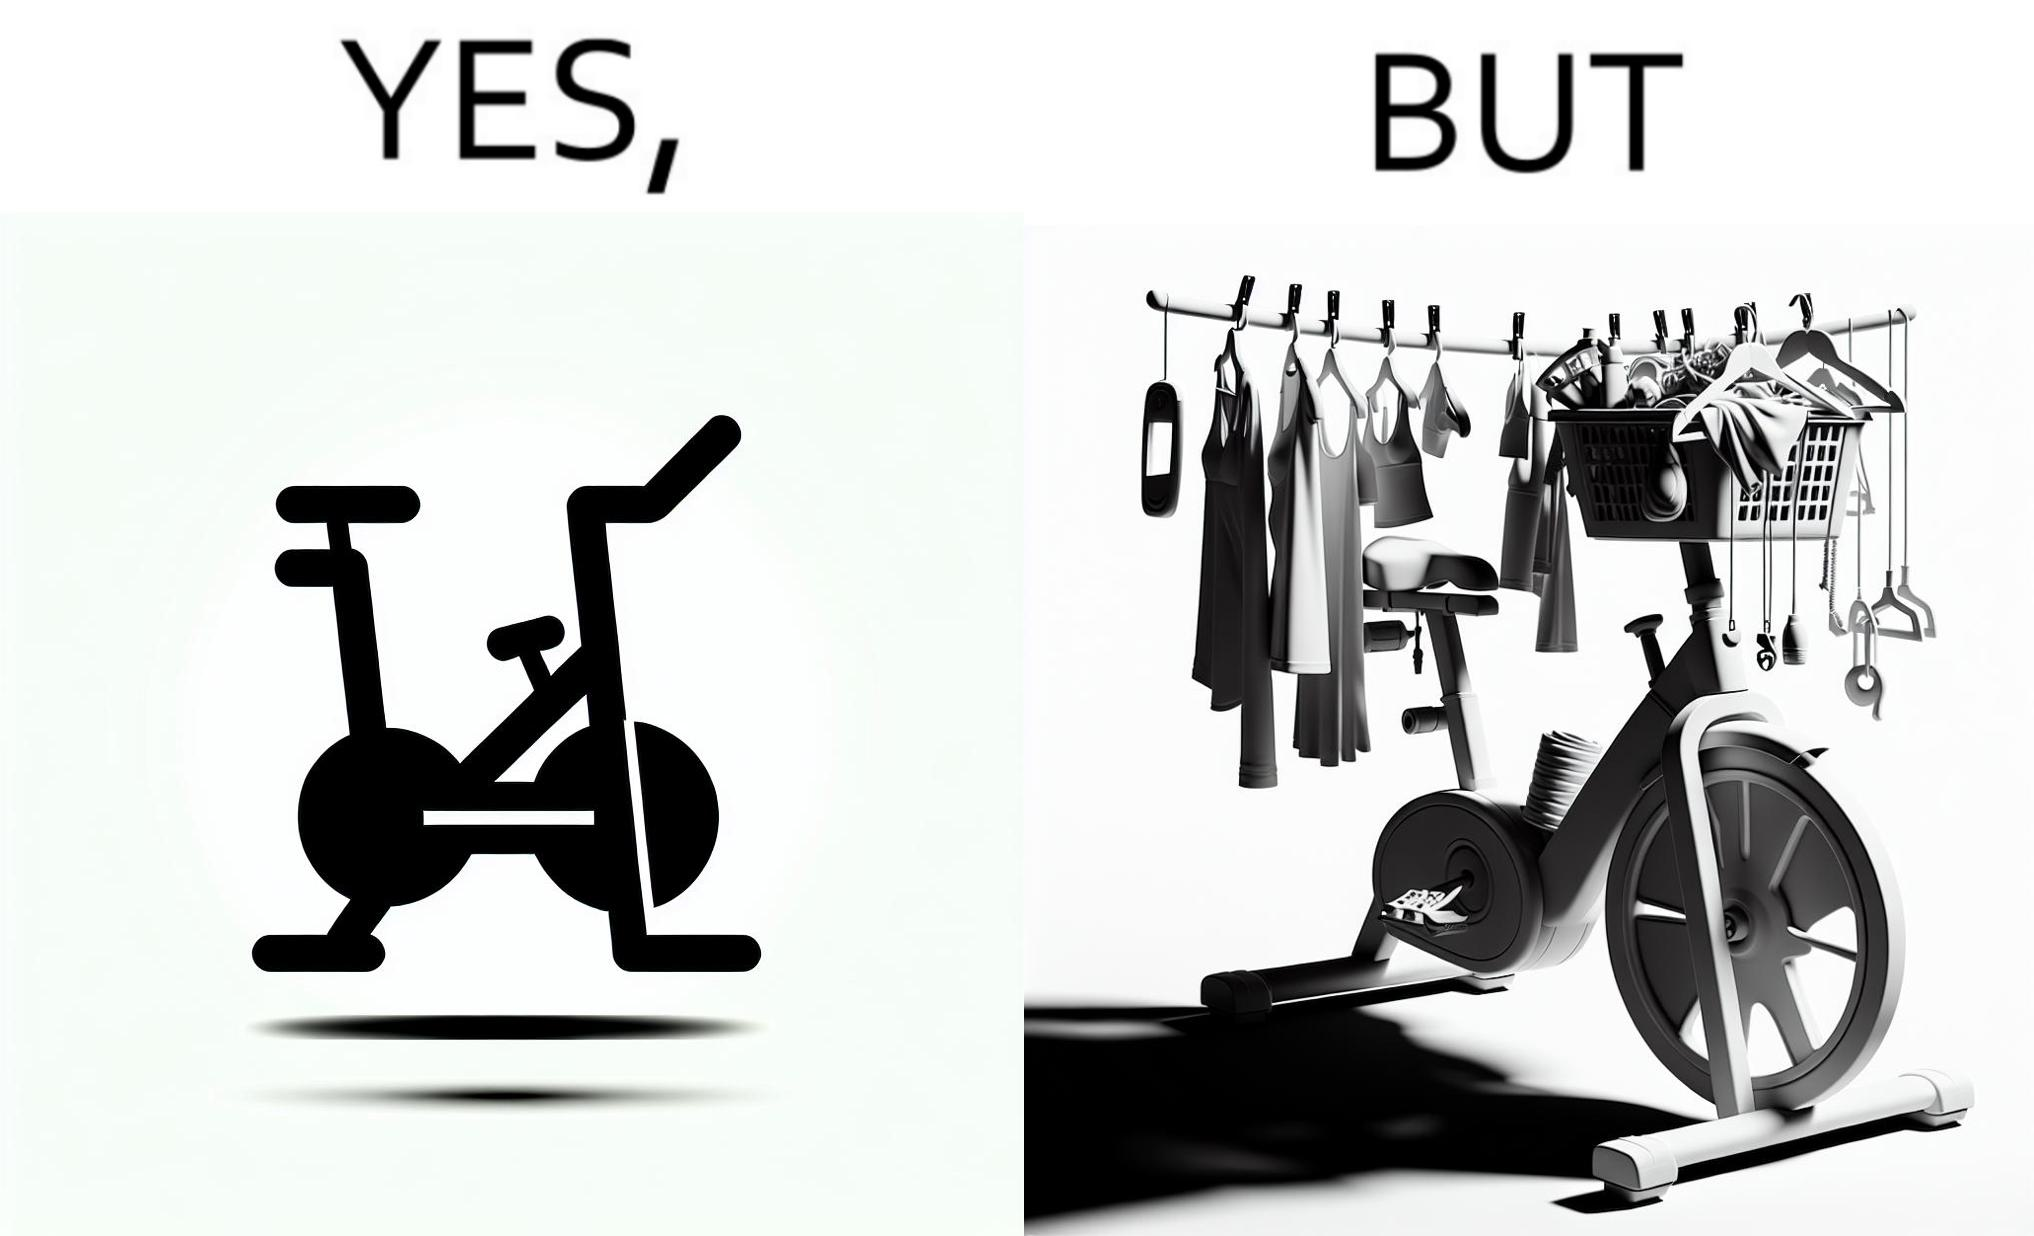Provide a description of this image. The images are funny since they show an exercise bike has been bought but is not being used for its purpose, that is, exercising. It is rather being used to hang clothes, bags and other items 